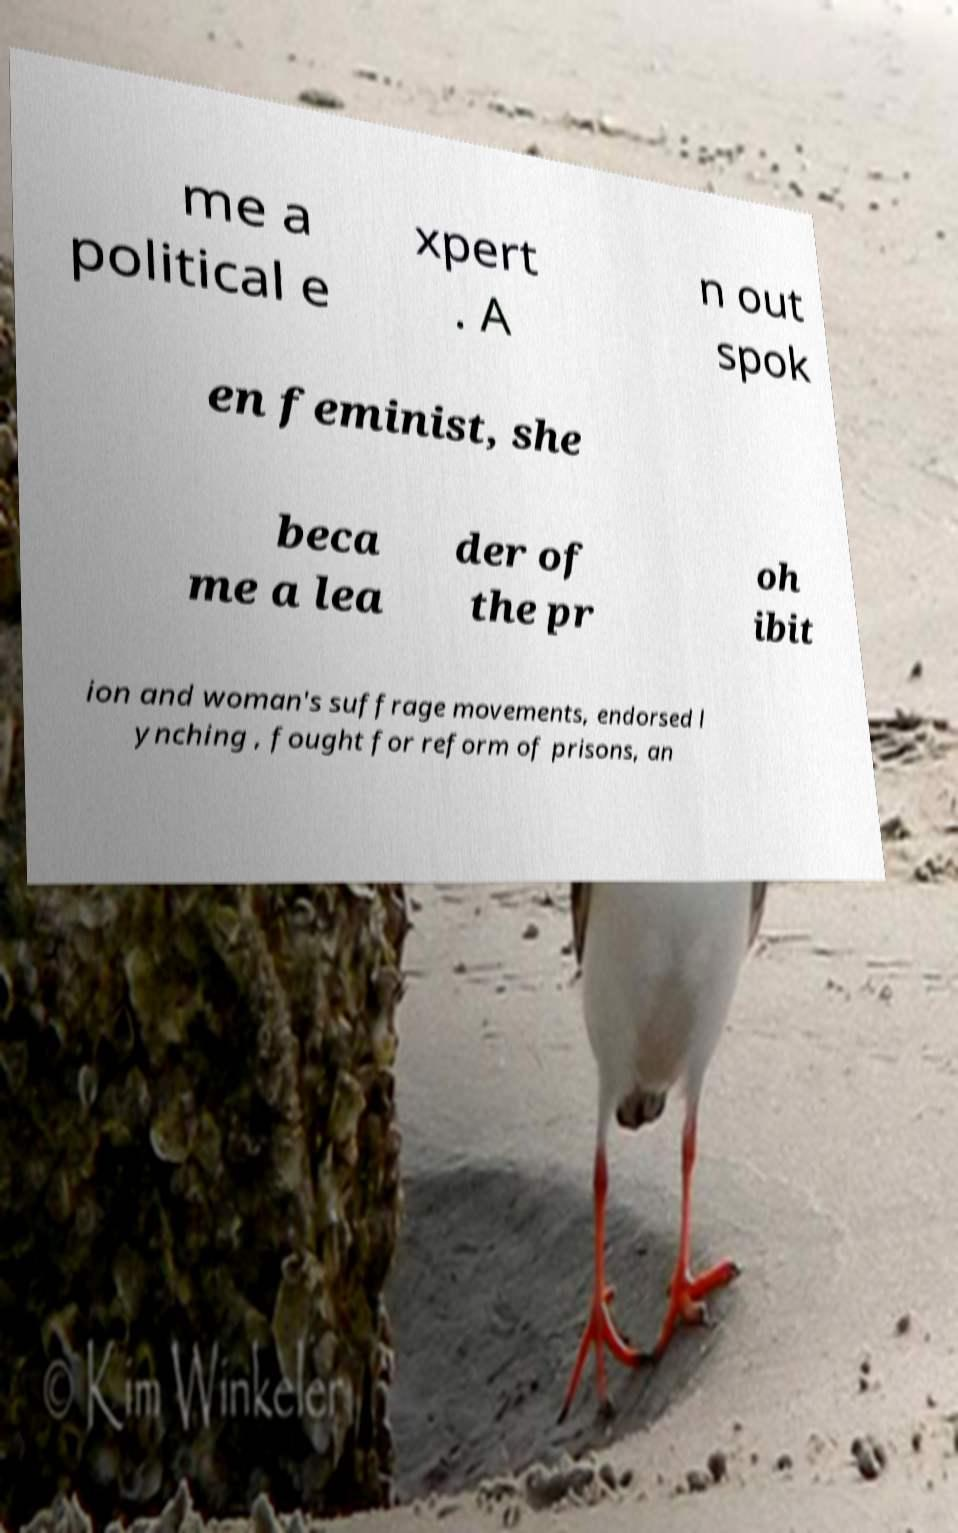Can you read and provide the text displayed in the image?This photo seems to have some interesting text. Can you extract and type it out for me? me a political e xpert . A n out spok en feminist, she beca me a lea der of the pr oh ibit ion and woman's suffrage movements, endorsed l ynching , fought for reform of prisons, an 